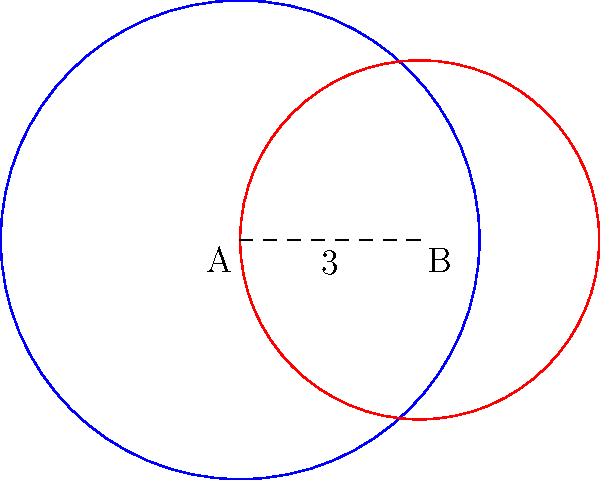In a kickboxing match analysis, two fighters' strike zones are represented by overlapping circles. Fighter A's zone is shown by the blue circle with radius 4 meters, while Fighter B's zone is the red circle with radius 3 meters. The centers of these circles are 3 meters apart. Calculate the area of overlap between these two strike zones, rounded to two decimal places. To find the area of overlap between two circles, we'll use the following steps:

1) First, we need to calculate the distance $d$ between the centers of the circles:
   $d = 3$ meters (given in the problem)

2) Let $R = 4$ (radius of larger circle) and $r = 3$ (radius of smaller circle)

3) We'll use the formula for the area of intersection of two circles:

   $A = R^2 \arccos(\frac{d^2 + R^2 - r^2}{2dR}) + r^2 \arccos(\frac{d^2 + r^2 - R^2}{2dr}) - \frac{1}{2}\sqrt{(-d+r+R)(d+r-R)(d-r+R)(d+r+R)}$

4) Substituting our values:

   $A = 4^2 \arccos(\frac{3^2 + 4^2 - 3^2}{2 \cdot 3 \cdot 4}) + 3^2 \arccos(\frac{3^2 + 3^2 - 4^2}{2 \cdot 3 \cdot 3}) - \frac{1}{2}\sqrt{(-3+3+4)(3+3-4)(3-3+4)(3+3+4)}$

5) Simplifying:

   $A = 16 \arccos(\frac{25}{24}) + 9 \arccos(\frac{10}{18}) - \frac{1}{2}\sqrt{4 \cdot 2 \cdot 4 \cdot 10}$

6) Calculating:

   $A \approx 16 \cdot 0.2534 + 9 \cdot 1.0472 - \frac{1}{2}\sqrt{320}$
   $A \approx 4.0544 + 9.4248 - 8.9443$
   $A \approx 4.5349$ square meters

7) Rounding to two decimal places:

   $A \approx 4.53$ square meters
Answer: 4.53 square meters 